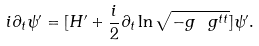<formula> <loc_0><loc_0><loc_500><loc_500>i \partial _ { t } \psi ^ { \prime } = [ H ^ { \prime } + \frac { i } { 2 } \partial _ { t } \ln \sqrt { - g \ g ^ { t t } } ] \psi ^ { \prime } .</formula> 